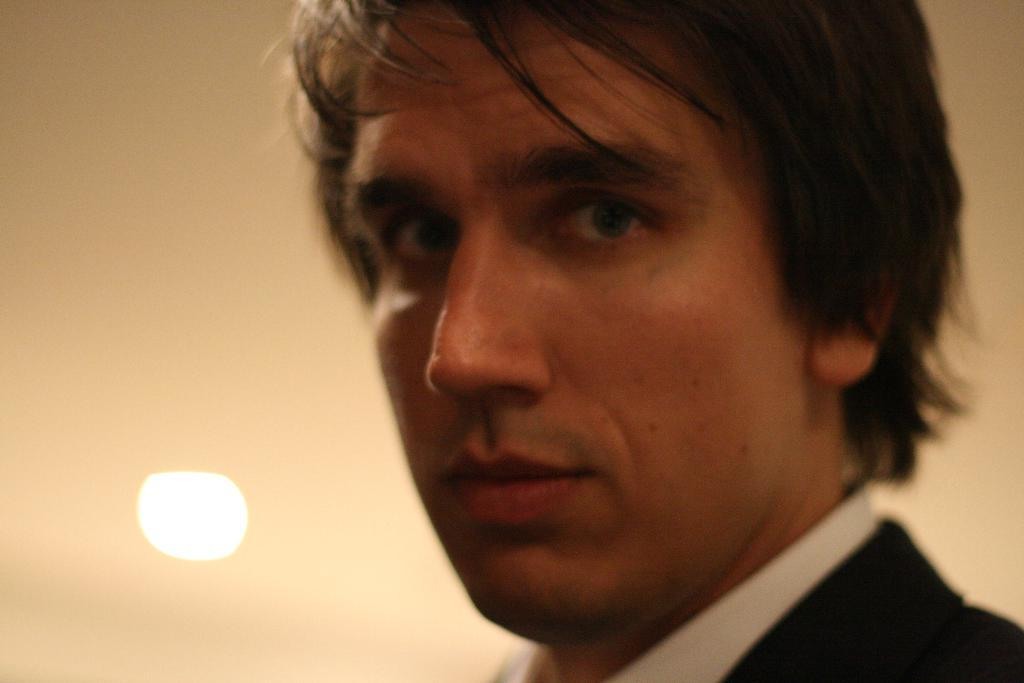What is the main subject of the image? There is a man in the image. What type of lumber is the man using to fly his kite in the image? There is no lumber or kite present in the image; it only features a man. 